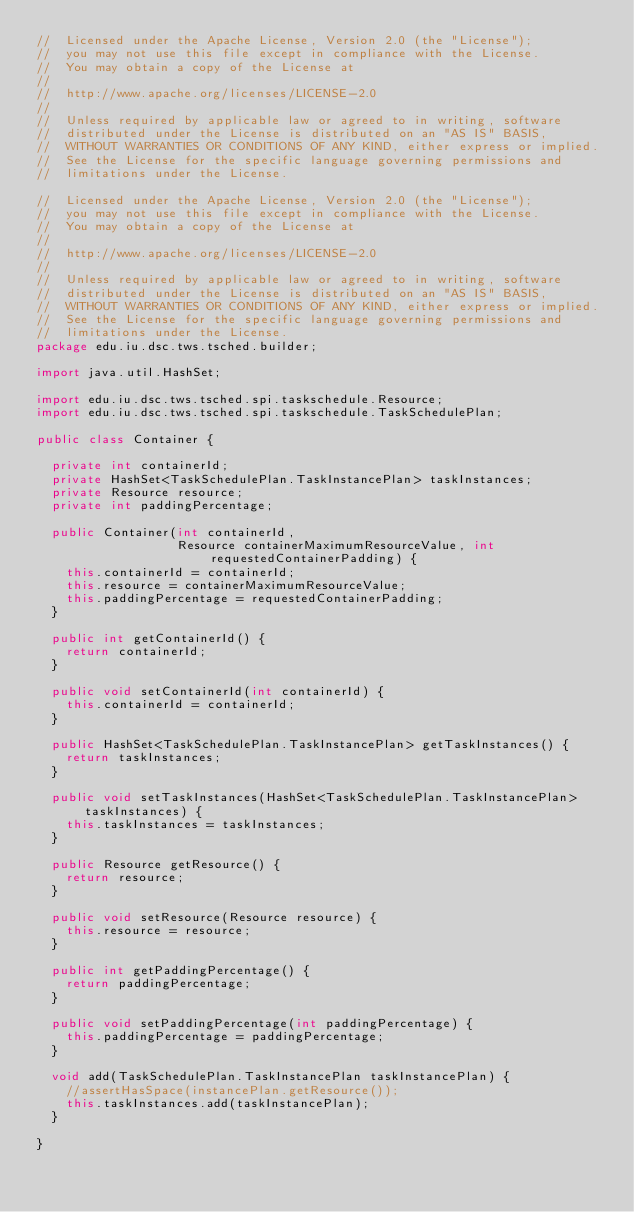Convert code to text. <code><loc_0><loc_0><loc_500><loc_500><_Java_>//  Licensed under the Apache License, Version 2.0 (the "License");
//  you may not use this file except in compliance with the License.
//  You may obtain a copy of the License at
//
//  http://www.apache.org/licenses/LICENSE-2.0
//
//  Unless required by applicable law or agreed to in writing, software
//  distributed under the License is distributed on an "AS IS" BASIS,
//  WITHOUT WARRANTIES OR CONDITIONS OF ANY KIND, either express or implied.
//  See the License for the specific language governing permissions and
//  limitations under the License.

//  Licensed under the Apache License, Version 2.0 (the "License");
//  you may not use this file except in compliance with the License.
//  You may obtain a copy of the License at
//
//  http://www.apache.org/licenses/LICENSE-2.0
//
//  Unless required by applicable law or agreed to in writing, software
//  distributed under the License is distributed on an "AS IS" BASIS,
//  WITHOUT WARRANTIES OR CONDITIONS OF ANY KIND, either express or implied.
//  See the License for the specific language governing permissions and
//  limitations under the License.
package edu.iu.dsc.tws.tsched.builder;

import java.util.HashSet;

import edu.iu.dsc.tws.tsched.spi.taskschedule.Resource;
import edu.iu.dsc.tws.tsched.spi.taskschedule.TaskSchedulePlan;

public class Container {

  private int containerId;
  private HashSet<TaskSchedulePlan.TaskInstancePlan> taskInstances;
  private Resource resource;
  private int paddingPercentage;

  public Container(int containerId,
                   Resource containerMaximumResourceValue, int requestedContainerPadding) {
    this.containerId = containerId;
    this.resource = containerMaximumResourceValue;
    this.paddingPercentage = requestedContainerPadding;
  }

  public int getContainerId() {
    return containerId;
  }

  public void setContainerId(int containerId) {
    this.containerId = containerId;
  }

  public HashSet<TaskSchedulePlan.TaskInstancePlan> getTaskInstances() {
    return taskInstances;
  }

  public void setTaskInstances(HashSet<TaskSchedulePlan.TaskInstancePlan> taskInstances) {
    this.taskInstances = taskInstances;
  }

  public Resource getResource() {
    return resource;
  }

  public void setResource(Resource resource) {
    this.resource = resource;
  }

  public int getPaddingPercentage() {
    return paddingPercentage;
  }

  public void setPaddingPercentage(int paddingPercentage) {
    this.paddingPercentage = paddingPercentage;
  }

  void add(TaskSchedulePlan.TaskInstancePlan taskInstancePlan) {
    //assertHasSpace(instancePlan.getResource());
    this.taskInstances.add(taskInstancePlan);
  }

}

</code> 